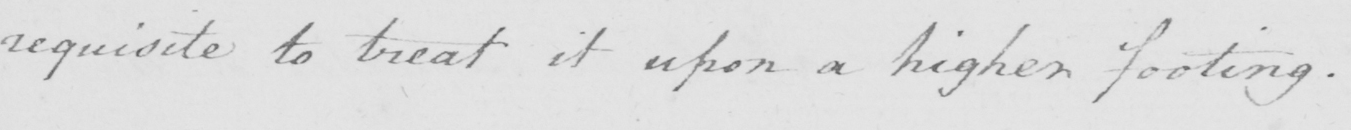What text is written in this handwritten line? requisite to treat it upon a higher footing . 